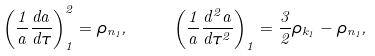<formula> <loc_0><loc_0><loc_500><loc_500>\left ( \frac { 1 } { a } \frac { d a } { d \tau } \right ) ^ { 2 } _ { 1 } = \rho _ { n _ { 1 } } , \quad \left ( \frac { 1 } { a } \frac { d ^ { 2 } a } { d \tau ^ { 2 } } \right ) _ { 1 } = \frac { 3 } { 2 } \rho _ { k _ { 1 } } - \rho _ { n _ { 1 } } ,</formula> 